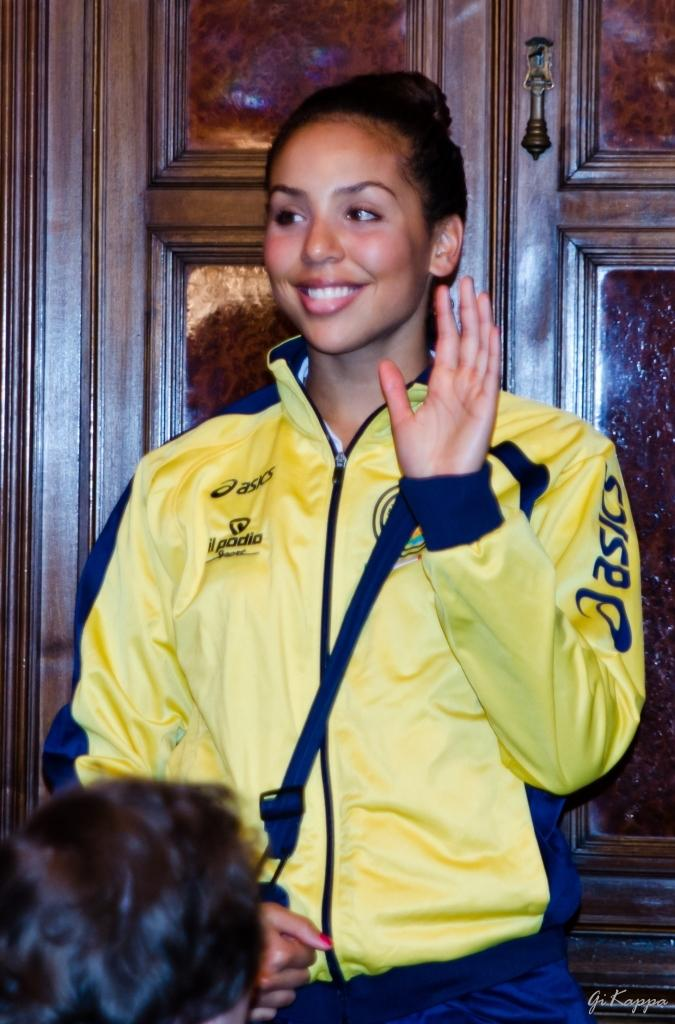<image>
Create a compact narrative representing the image presented. A woman waving at a crowd while wearing a yellow wind breaker with an asics logo on her left arm. 